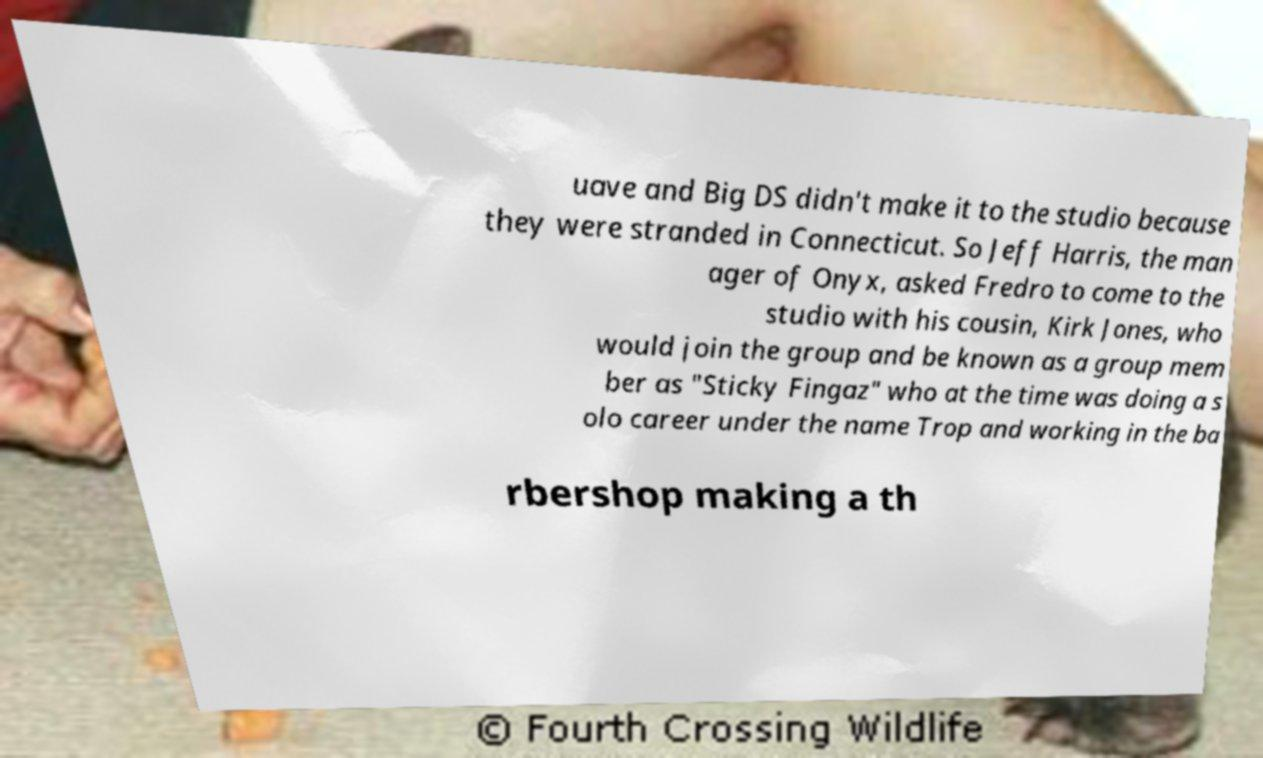For documentation purposes, I need the text within this image transcribed. Could you provide that? uave and Big DS didn't make it to the studio because they were stranded in Connecticut. So Jeff Harris, the man ager of Onyx, asked Fredro to come to the studio with his cousin, Kirk Jones, who would join the group and be known as a group mem ber as "Sticky Fingaz" who at the time was doing a s olo career under the name Trop and working in the ba rbershop making a th 